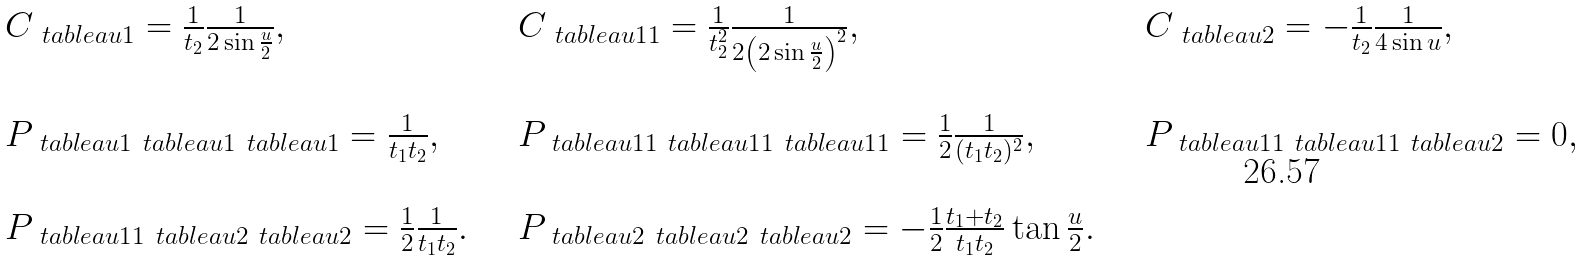<formula> <loc_0><loc_0><loc_500><loc_500>\begin{array} { l l l } C _ { \ t a b l e a u { 1 } } = \frac { 1 } { t _ { 2 } } \frac { 1 } { 2 \sin \frac { u } { 2 } } , & \quad C _ { \ t a b l e a u { 1 1 } } = \frac { 1 } { t _ { 2 } ^ { 2 } } \frac { 1 } { 2 \left ( 2 \sin \frac { u } { 2 } \right ) ^ { 2 } } , & \quad C _ { \ t a b l e a u { 2 } } = - \frac { 1 } { t _ { 2 } } \frac { 1 } { 4 \sin u } , \\ & & \\ P _ { \ t a b l e a u { 1 } \ t a b l e a u { 1 } \ t a b l e a u { 1 } } = \frac { 1 } { t _ { 1 } t _ { 2 } } , & \quad P _ { \ t a b l e a u { 1 1 } \ t a b l e a u { 1 1 } \ t a b l e a u { 1 1 } } = \frac { 1 } { 2 } \frac { 1 } { ( t _ { 1 } t _ { 2 } ) ^ { 2 } } , & \quad P _ { \ t a b l e a u { 1 1 } \ t a b l e a u { 1 1 } \ t a b l e a u { 2 } } = 0 , \\ & & \\ P _ { \ t a b l e a u { 1 1 } \ t a b l e a u { 2 } \ t a b l e a u { 2 } } = \frac { 1 } { 2 } \frac { 1 } { t _ { 1 } t _ { 2 } } . & \quad P _ { \ t a b l e a u { 2 } \ t a b l e a u { 2 } \ t a b l e a u { 2 } } = - \frac { 1 } { 2 } \frac { t _ { 1 } + t _ { 2 } } { t _ { 1 } t _ { 2 } } \tan \frac { u } { 2 } . & \quad \\ \end{array}</formula> 